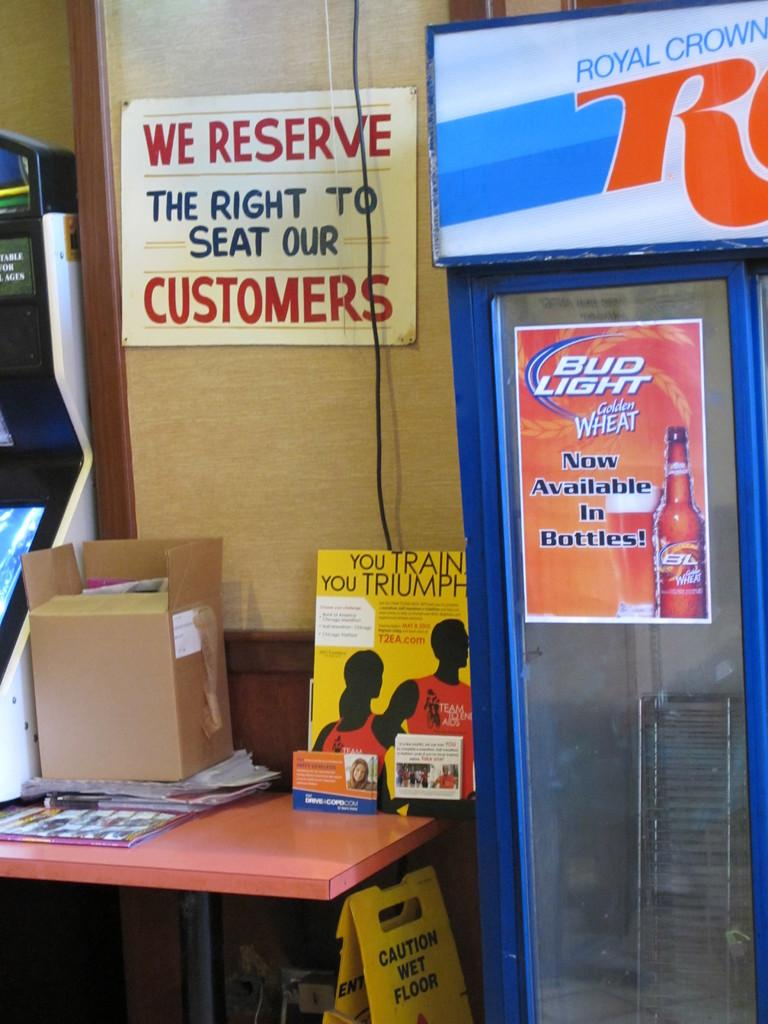What is the main piece of furniture in the image? There is a table in the image. What is placed on the table? There is a cardboard box and posters on the table. Can you describe the refrigerator in the image? The refrigerator has a sticker on it. What can be seen on the wall in the background? There is a board on the wall in the background. How many daughters are visible in the image? There are no daughters present in the image. What type of snakes can be seen slithering on the table? There are no snakes present in the image. 